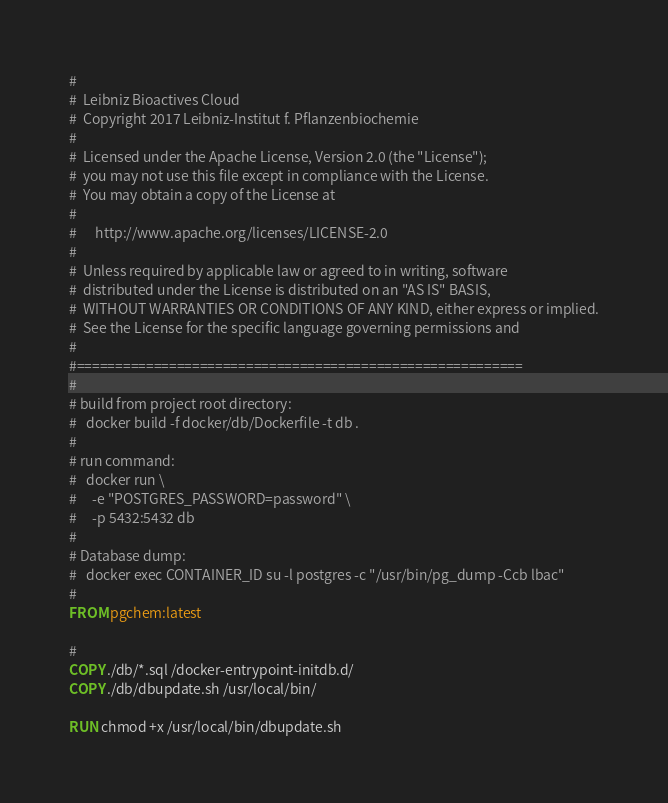<code> <loc_0><loc_0><loc_500><loc_500><_Dockerfile_>#
#  Leibniz Bioactives Cloud
#  Copyright 2017 Leibniz-Institut f. Pflanzenbiochemie
#
#  Licensed under the Apache License, Version 2.0 (the "License");
#  you may not use this file except in compliance with the License.
#  You may obtain a copy of the License at
#
#      http://www.apache.org/licenses/LICENSE-2.0
#
#  Unless required by applicable law or agreed to in writing, software
#  distributed under the License is distributed on an "AS IS" BASIS,
#  WITHOUT WARRANTIES OR CONDITIONS OF ANY KIND, either express or implied.
#  See the License for the specific language governing permissions and
#
#==========================================================
#
# build from project root directory:
#	docker build -f docker/db/Dockerfile -t db .
#
# run command: 
#	docker run \
#	  -e "POSTGRES_PASSWORD=password" \
#	  -p 5432:5432 db
#
# Database dump:
# 	docker exec CONTAINER_ID su -l postgres -c "/usr/bin/pg_dump -Ccb lbac"
#
FROM pgchem:latest

#
COPY ./db/*.sql /docker-entrypoint-initdb.d/
COPY ./db/dbupdate.sh /usr/local/bin/

RUN chmod +x /usr/local/bin/dbupdate.sh

</code> 